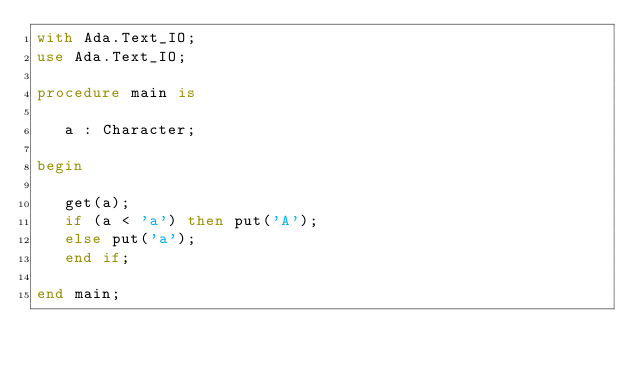<code> <loc_0><loc_0><loc_500><loc_500><_Ada_>with Ada.Text_IO;
use Ada.Text_IO;

procedure main is

   a : Character;

begin

   get(a);
   if (a < 'a') then put('A');
   else put('a');
   end if;
   
end main;</code> 